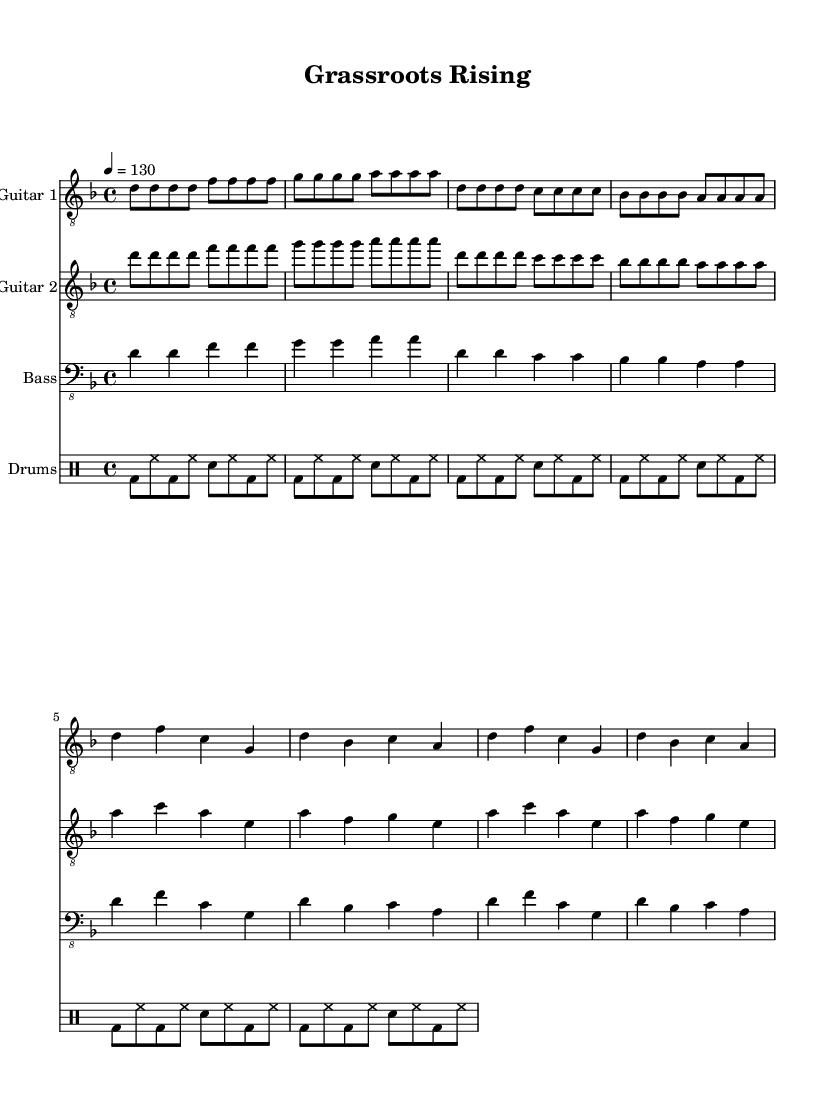What is the key signature of this music? The key signature is indicated at the beginning of the music and shows two flats, which is characteristic of D minor.
Answer: D minor What is the time signature of this music? The time signature is shown at the beginning of the sheet music, which indicates that there are four beats per measure.
Answer: 4/4 What is the tempo marking for this composition? The tempo marking is written as a metronomic marking at the beginning, indicating a speed of 130 beats per minute.
Answer: 130 How many measures are in the main riff section? The main riff, as observed in the guitar parts, contains a total of eight measures.
Answer: 8 In the verse section, which chords are primarily used? By looking at the guitar and bass sections, the chords d, f, c, and g are consistently played in the verse section.
Answer: d, f, c, g What type of drum pattern is used in the chorus? The drum pattern remains consistent with a beat that includes bass and snare accents in a typical metal rhythm.
Answer: Metal rhythm What is the primary harmonic progression in the chorus? The harmonic progression can be deduced by examining the chords played in both guitar parts during the chorus, revealing a structure similar to that in the verse, reinforcing the themes.
Answer: d, f, c, g 